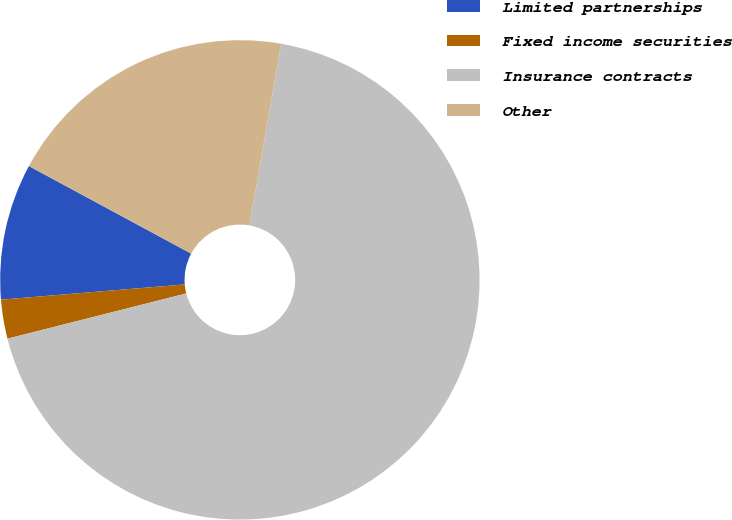Convert chart to OTSL. <chart><loc_0><loc_0><loc_500><loc_500><pie_chart><fcel>Limited partnerships<fcel>Fixed income securities<fcel>Insurance contracts<fcel>Other<nl><fcel>9.19%<fcel>2.63%<fcel>68.3%<fcel>19.88%<nl></chart> 